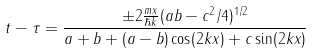<formula> <loc_0><loc_0><loc_500><loc_500>t - \tau = \frac { \pm 2 \frac { m x } { \hbar { k } } ( a b - c ^ { 2 } / 4 ) ^ { 1 / 2 } } { a + b + ( a - b ) \cos ( 2 k x ) + c \sin ( 2 k x ) }</formula> 